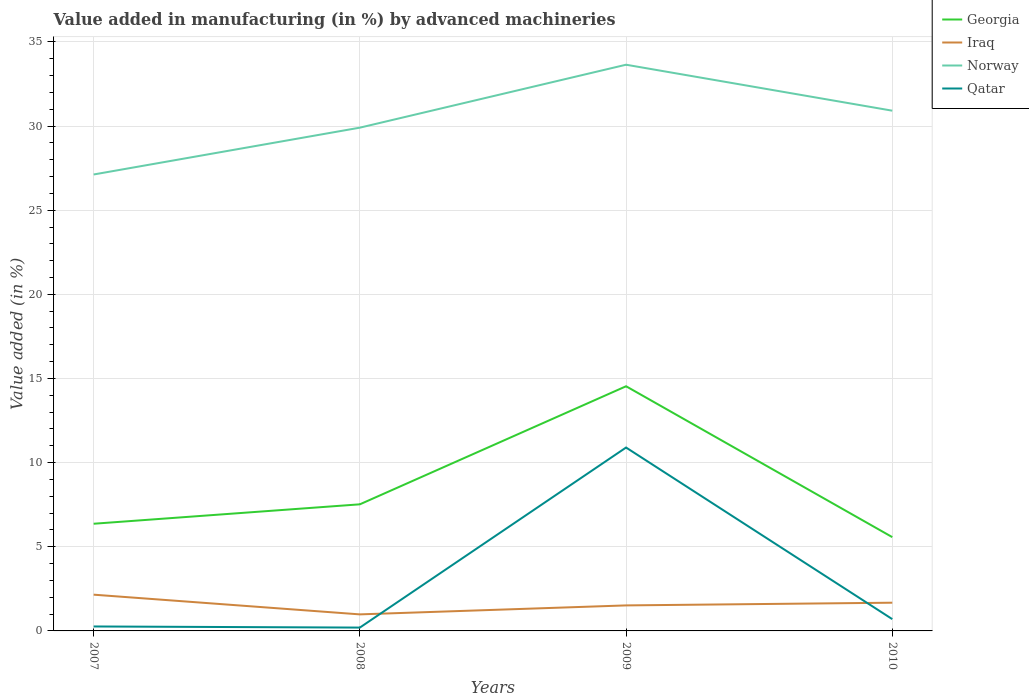How many different coloured lines are there?
Offer a terse response. 4. Is the number of lines equal to the number of legend labels?
Your answer should be very brief. Yes. Across all years, what is the maximum percentage of value added in manufacturing by advanced machineries in Georgia?
Offer a very short reply. 5.57. What is the total percentage of value added in manufacturing by advanced machineries in Qatar in the graph?
Make the answer very short. 0.07. What is the difference between the highest and the second highest percentage of value added in manufacturing by advanced machineries in Norway?
Keep it short and to the point. 6.52. Is the percentage of value added in manufacturing by advanced machineries in Qatar strictly greater than the percentage of value added in manufacturing by advanced machineries in Iraq over the years?
Keep it short and to the point. No. How many lines are there?
Your response must be concise. 4. What is the difference between two consecutive major ticks on the Y-axis?
Ensure brevity in your answer.  5. How many legend labels are there?
Ensure brevity in your answer.  4. What is the title of the graph?
Make the answer very short. Value added in manufacturing (in %) by advanced machineries. Does "China" appear as one of the legend labels in the graph?
Your answer should be very brief. No. What is the label or title of the X-axis?
Offer a terse response. Years. What is the label or title of the Y-axis?
Offer a very short reply. Value added (in %). What is the Value added (in %) of Georgia in 2007?
Give a very brief answer. 6.37. What is the Value added (in %) in Iraq in 2007?
Give a very brief answer. 2.15. What is the Value added (in %) of Norway in 2007?
Offer a very short reply. 27.12. What is the Value added (in %) of Qatar in 2007?
Ensure brevity in your answer.  0.26. What is the Value added (in %) in Georgia in 2008?
Your answer should be compact. 7.52. What is the Value added (in %) in Iraq in 2008?
Make the answer very short. 0.98. What is the Value added (in %) of Norway in 2008?
Ensure brevity in your answer.  29.9. What is the Value added (in %) in Qatar in 2008?
Your answer should be compact. 0.2. What is the Value added (in %) of Georgia in 2009?
Your answer should be compact. 14.54. What is the Value added (in %) of Iraq in 2009?
Offer a terse response. 1.52. What is the Value added (in %) of Norway in 2009?
Offer a very short reply. 33.64. What is the Value added (in %) in Qatar in 2009?
Provide a succinct answer. 10.9. What is the Value added (in %) in Georgia in 2010?
Your response must be concise. 5.57. What is the Value added (in %) of Iraq in 2010?
Ensure brevity in your answer.  1.68. What is the Value added (in %) in Norway in 2010?
Offer a very short reply. 30.91. What is the Value added (in %) of Qatar in 2010?
Offer a terse response. 0.7. Across all years, what is the maximum Value added (in %) of Georgia?
Offer a terse response. 14.54. Across all years, what is the maximum Value added (in %) of Iraq?
Offer a terse response. 2.15. Across all years, what is the maximum Value added (in %) of Norway?
Give a very brief answer. 33.64. Across all years, what is the maximum Value added (in %) of Qatar?
Offer a very short reply. 10.9. Across all years, what is the minimum Value added (in %) in Georgia?
Your answer should be compact. 5.57. Across all years, what is the minimum Value added (in %) of Iraq?
Provide a short and direct response. 0.98. Across all years, what is the minimum Value added (in %) of Norway?
Provide a short and direct response. 27.12. Across all years, what is the minimum Value added (in %) in Qatar?
Ensure brevity in your answer.  0.2. What is the total Value added (in %) in Georgia in the graph?
Keep it short and to the point. 34. What is the total Value added (in %) of Iraq in the graph?
Your response must be concise. 6.33. What is the total Value added (in %) of Norway in the graph?
Make the answer very short. 121.58. What is the total Value added (in %) in Qatar in the graph?
Keep it short and to the point. 12.06. What is the difference between the Value added (in %) in Georgia in 2007 and that in 2008?
Offer a terse response. -1.15. What is the difference between the Value added (in %) in Iraq in 2007 and that in 2008?
Provide a short and direct response. 1.17. What is the difference between the Value added (in %) of Norway in 2007 and that in 2008?
Your answer should be compact. -2.78. What is the difference between the Value added (in %) of Qatar in 2007 and that in 2008?
Offer a very short reply. 0.07. What is the difference between the Value added (in %) in Georgia in 2007 and that in 2009?
Give a very brief answer. -8.17. What is the difference between the Value added (in %) of Iraq in 2007 and that in 2009?
Give a very brief answer. 0.64. What is the difference between the Value added (in %) of Norway in 2007 and that in 2009?
Offer a terse response. -6.52. What is the difference between the Value added (in %) of Qatar in 2007 and that in 2009?
Give a very brief answer. -10.63. What is the difference between the Value added (in %) of Georgia in 2007 and that in 2010?
Your response must be concise. 0.79. What is the difference between the Value added (in %) in Iraq in 2007 and that in 2010?
Ensure brevity in your answer.  0.48. What is the difference between the Value added (in %) in Norway in 2007 and that in 2010?
Your answer should be very brief. -3.79. What is the difference between the Value added (in %) in Qatar in 2007 and that in 2010?
Your response must be concise. -0.44. What is the difference between the Value added (in %) in Georgia in 2008 and that in 2009?
Your response must be concise. -7.02. What is the difference between the Value added (in %) of Iraq in 2008 and that in 2009?
Make the answer very short. -0.53. What is the difference between the Value added (in %) in Norway in 2008 and that in 2009?
Provide a succinct answer. -3.74. What is the difference between the Value added (in %) of Qatar in 2008 and that in 2009?
Offer a terse response. -10.7. What is the difference between the Value added (in %) in Georgia in 2008 and that in 2010?
Ensure brevity in your answer.  1.95. What is the difference between the Value added (in %) in Iraq in 2008 and that in 2010?
Make the answer very short. -0.69. What is the difference between the Value added (in %) of Norway in 2008 and that in 2010?
Your answer should be very brief. -1.01. What is the difference between the Value added (in %) of Qatar in 2008 and that in 2010?
Keep it short and to the point. -0.5. What is the difference between the Value added (in %) of Georgia in 2009 and that in 2010?
Provide a succinct answer. 8.96. What is the difference between the Value added (in %) of Iraq in 2009 and that in 2010?
Your answer should be very brief. -0.16. What is the difference between the Value added (in %) in Norway in 2009 and that in 2010?
Make the answer very short. 2.73. What is the difference between the Value added (in %) of Qatar in 2009 and that in 2010?
Ensure brevity in your answer.  10.2. What is the difference between the Value added (in %) of Georgia in 2007 and the Value added (in %) of Iraq in 2008?
Your answer should be very brief. 5.39. What is the difference between the Value added (in %) of Georgia in 2007 and the Value added (in %) of Norway in 2008?
Provide a succinct answer. -23.53. What is the difference between the Value added (in %) in Georgia in 2007 and the Value added (in %) in Qatar in 2008?
Give a very brief answer. 6.17. What is the difference between the Value added (in %) of Iraq in 2007 and the Value added (in %) of Norway in 2008?
Keep it short and to the point. -27.75. What is the difference between the Value added (in %) in Iraq in 2007 and the Value added (in %) in Qatar in 2008?
Your answer should be very brief. 1.96. What is the difference between the Value added (in %) in Norway in 2007 and the Value added (in %) in Qatar in 2008?
Offer a very short reply. 26.92. What is the difference between the Value added (in %) in Georgia in 2007 and the Value added (in %) in Iraq in 2009?
Offer a very short reply. 4.85. What is the difference between the Value added (in %) in Georgia in 2007 and the Value added (in %) in Norway in 2009?
Keep it short and to the point. -27.27. What is the difference between the Value added (in %) in Georgia in 2007 and the Value added (in %) in Qatar in 2009?
Offer a very short reply. -4.53. What is the difference between the Value added (in %) in Iraq in 2007 and the Value added (in %) in Norway in 2009?
Your response must be concise. -31.49. What is the difference between the Value added (in %) in Iraq in 2007 and the Value added (in %) in Qatar in 2009?
Your answer should be compact. -8.74. What is the difference between the Value added (in %) of Norway in 2007 and the Value added (in %) of Qatar in 2009?
Your response must be concise. 16.22. What is the difference between the Value added (in %) of Georgia in 2007 and the Value added (in %) of Iraq in 2010?
Offer a very short reply. 4.69. What is the difference between the Value added (in %) in Georgia in 2007 and the Value added (in %) in Norway in 2010?
Provide a succinct answer. -24.54. What is the difference between the Value added (in %) of Georgia in 2007 and the Value added (in %) of Qatar in 2010?
Your answer should be very brief. 5.67. What is the difference between the Value added (in %) of Iraq in 2007 and the Value added (in %) of Norway in 2010?
Your answer should be compact. -28.76. What is the difference between the Value added (in %) in Iraq in 2007 and the Value added (in %) in Qatar in 2010?
Your response must be concise. 1.45. What is the difference between the Value added (in %) in Norway in 2007 and the Value added (in %) in Qatar in 2010?
Your response must be concise. 26.42. What is the difference between the Value added (in %) in Georgia in 2008 and the Value added (in %) in Iraq in 2009?
Your answer should be very brief. 6.01. What is the difference between the Value added (in %) of Georgia in 2008 and the Value added (in %) of Norway in 2009?
Your answer should be very brief. -26.12. What is the difference between the Value added (in %) of Georgia in 2008 and the Value added (in %) of Qatar in 2009?
Provide a succinct answer. -3.37. What is the difference between the Value added (in %) in Iraq in 2008 and the Value added (in %) in Norway in 2009?
Provide a short and direct response. -32.66. What is the difference between the Value added (in %) in Iraq in 2008 and the Value added (in %) in Qatar in 2009?
Make the answer very short. -9.91. What is the difference between the Value added (in %) of Norway in 2008 and the Value added (in %) of Qatar in 2009?
Offer a terse response. 19.01. What is the difference between the Value added (in %) in Georgia in 2008 and the Value added (in %) in Iraq in 2010?
Keep it short and to the point. 5.85. What is the difference between the Value added (in %) of Georgia in 2008 and the Value added (in %) of Norway in 2010?
Provide a short and direct response. -23.39. What is the difference between the Value added (in %) in Georgia in 2008 and the Value added (in %) in Qatar in 2010?
Your response must be concise. 6.82. What is the difference between the Value added (in %) in Iraq in 2008 and the Value added (in %) in Norway in 2010?
Make the answer very short. -29.93. What is the difference between the Value added (in %) of Iraq in 2008 and the Value added (in %) of Qatar in 2010?
Offer a terse response. 0.28. What is the difference between the Value added (in %) in Norway in 2008 and the Value added (in %) in Qatar in 2010?
Ensure brevity in your answer.  29.2. What is the difference between the Value added (in %) in Georgia in 2009 and the Value added (in %) in Iraq in 2010?
Your answer should be compact. 12.86. What is the difference between the Value added (in %) of Georgia in 2009 and the Value added (in %) of Norway in 2010?
Keep it short and to the point. -16.37. What is the difference between the Value added (in %) in Georgia in 2009 and the Value added (in %) in Qatar in 2010?
Your answer should be compact. 13.84. What is the difference between the Value added (in %) in Iraq in 2009 and the Value added (in %) in Norway in 2010?
Provide a short and direct response. -29.39. What is the difference between the Value added (in %) of Iraq in 2009 and the Value added (in %) of Qatar in 2010?
Provide a short and direct response. 0.82. What is the difference between the Value added (in %) of Norway in 2009 and the Value added (in %) of Qatar in 2010?
Your response must be concise. 32.94. What is the average Value added (in %) of Georgia per year?
Make the answer very short. 8.5. What is the average Value added (in %) of Iraq per year?
Provide a short and direct response. 1.58. What is the average Value added (in %) of Norway per year?
Offer a very short reply. 30.39. What is the average Value added (in %) in Qatar per year?
Make the answer very short. 3.02. In the year 2007, what is the difference between the Value added (in %) in Georgia and Value added (in %) in Iraq?
Offer a very short reply. 4.21. In the year 2007, what is the difference between the Value added (in %) of Georgia and Value added (in %) of Norway?
Ensure brevity in your answer.  -20.75. In the year 2007, what is the difference between the Value added (in %) of Georgia and Value added (in %) of Qatar?
Make the answer very short. 6.1. In the year 2007, what is the difference between the Value added (in %) of Iraq and Value added (in %) of Norway?
Provide a short and direct response. -24.97. In the year 2007, what is the difference between the Value added (in %) of Iraq and Value added (in %) of Qatar?
Offer a very short reply. 1.89. In the year 2007, what is the difference between the Value added (in %) of Norway and Value added (in %) of Qatar?
Give a very brief answer. 26.86. In the year 2008, what is the difference between the Value added (in %) in Georgia and Value added (in %) in Iraq?
Make the answer very short. 6.54. In the year 2008, what is the difference between the Value added (in %) of Georgia and Value added (in %) of Norway?
Provide a short and direct response. -22.38. In the year 2008, what is the difference between the Value added (in %) of Georgia and Value added (in %) of Qatar?
Make the answer very short. 7.32. In the year 2008, what is the difference between the Value added (in %) in Iraq and Value added (in %) in Norway?
Keep it short and to the point. -28.92. In the year 2008, what is the difference between the Value added (in %) in Iraq and Value added (in %) in Qatar?
Ensure brevity in your answer.  0.78. In the year 2008, what is the difference between the Value added (in %) of Norway and Value added (in %) of Qatar?
Ensure brevity in your answer.  29.7. In the year 2009, what is the difference between the Value added (in %) in Georgia and Value added (in %) in Iraq?
Offer a terse response. 13.02. In the year 2009, what is the difference between the Value added (in %) in Georgia and Value added (in %) in Norway?
Your answer should be compact. -19.11. In the year 2009, what is the difference between the Value added (in %) in Georgia and Value added (in %) in Qatar?
Provide a short and direct response. 3.64. In the year 2009, what is the difference between the Value added (in %) of Iraq and Value added (in %) of Norway?
Provide a short and direct response. -32.13. In the year 2009, what is the difference between the Value added (in %) of Iraq and Value added (in %) of Qatar?
Offer a terse response. -9.38. In the year 2009, what is the difference between the Value added (in %) in Norway and Value added (in %) in Qatar?
Offer a terse response. 22.75. In the year 2010, what is the difference between the Value added (in %) of Georgia and Value added (in %) of Iraq?
Ensure brevity in your answer.  3.9. In the year 2010, what is the difference between the Value added (in %) in Georgia and Value added (in %) in Norway?
Give a very brief answer. -25.34. In the year 2010, what is the difference between the Value added (in %) in Georgia and Value added (in %) in Qatar?
Give a very brief answer. 4.87. In the year 2010, what is the difference between the Value added (in %) of Iraq and Value added (in %) of Norway?
Keep it short and to the point. -29.23. In the year 2010, what is the difference between the Value added (in %) in Iraq and Value added (in %) in Qatar?
Offer a very short reply. 0.98. In the year 2010, what is the difference between the Value added (in %) in Norway and Value added (in %) in Qatar?
Offer a terse response. 30.21. What is the ratio of the Value added (in %) in Georgia in 2007 to that in 2008?
Ensure brevity in your answer.  0.85. What is the ratio of the Value added (in %) of Iraq in 2007 to that in 2008?
Provide a succinct answer. 2.19. What is the ratio of the Value added (in %) in Norway in 2007 to that in 2008?
Your answer should be compact. 0.91. What is the ratio of the Value added (in %) in Qatar in 2007 to that in 2008?
Provide a succinct answer. 1.33. What is the ratio of the Value added (in %) in Georgia in 2007 to that in 2009?
Your response must be concise. 0.44. What is the ratio of the Value added (in %) of Iraq in 2007 to that in 2009?
Your response must be concise. 1.42. What is the ratio of the Value added (in %) in Norway in 2007 to that in 2009?
Make the answer very short. 0.81. What is the ratio of the Value added (in %) in Qatar in 2007 to that in 2009?
Make the answer very short. 0.02. What is the ratio of the Value added (in %) in Georgia in 2007 to that in 2010?
Give a very brief answer. 1.14. What is the ratio of the Value added (in %) in Iraq in 2007 to that in 2010?
Offer a very short reply. 1.28. What is the ratio of the Value added (in %) in Norway in 2007 to that in 2010?
Provide a succinct answer. 0.88. What is the ratio of the Value added (in %) in Qatar in 2007 to that in 2010?
Give a very brief answer. 0.38. What is the ratio of the Value added (in %) of Georgia in 2008 to that in 2009?
Give a very brief answer. 0.52. What is the ratio of the Value added (in %) in Iraq in 2008 to that in 2009?
Keep it short and to the point. 0.65. What is the ratio of the Value added (in %) in Norway in 2008 to that in 2009?
Keep it short and to the point. 0.89. What is the ratio of the Value added (in %) of Qatar in 2008 to that in 2009?
Provide a short and direct response. 0.02. What is the ratio of the Value added (in %) of Georgia in 2008 to that in 2010?
Provide a short and direct response. 1.35. What is the ratio of the Value added (in %) of Iraq in 2008 to that in 2010?
Keep it short and to the point. 0.59. What is the ratio of the Value added (in %) in Norway in 2008 to that in 2010?
Keep it short and to the point. 0.97. What is the ratio of the Value added (in %) in Qatar in 2008 to that in 2010?
Offer a terse response. 0.28. What is the ratio of the Value added (in %) of Georgia in 2009 to that in 2010?
Your answer should be compact. 2.61. What is the ratio of the Value added (in %) of Iraq in 2009 to that in 2010?
Offer a very short reply. 0.9. What is the ratio of the Value added (in %) in Norway in 2009 to that in 2010?
Provide a succinct answer. 1.09. What is the ratio of the Value added (in %) in Qatar in 2009 to that in 2010?
Provide a succinct answer. 15.55. What is the difference between the highest and the second highest Value added (in %) of Georgia?
Offer a very short reply. 7.02. What is the difference between the highest and the second highest Value added (in %) of Iraq?
Ensure brevity in your answer.  0.48. What is the difference between the highest and the second highest Value added (in %) of Norway?
Make the answer very short. 2.73. What is the difference between the highest and the second highest Value added (in %) in Qatar?
Offer a terse response. 10.2. What is the difference between the highest and the lowest Value added (in %) of Georgia?
Offer a terse response. 8.96. What is the difference between the highest and the lowest Value added (in %) in Iraq?
Offer a very short reply. 1.17. What is the difference between the highest and the lowest Value added (in %) of Norway?
Provide a short and direct response. 6.52. What is the difference between the highest and the lowest Value added (in %) in Qatar?
Offer a very short reply. 10.7. 